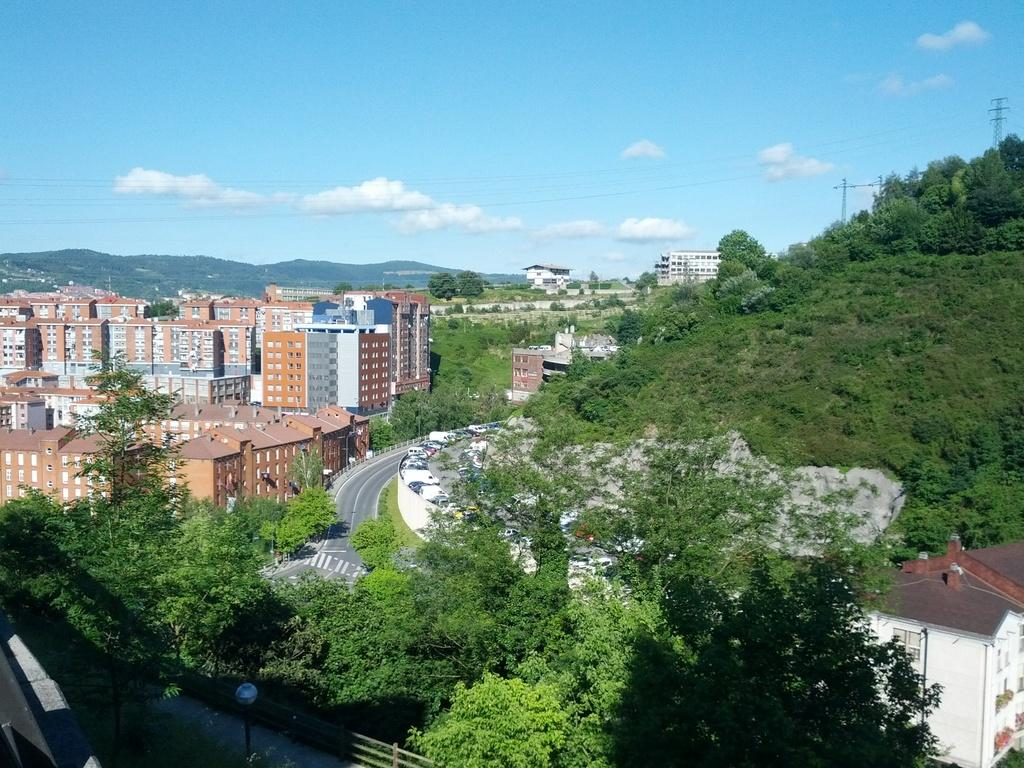What type of vegetation can be seen in the image? There are trees in the image. What is the color of the trees? The trees are green. What can be seen in the background of the image? There are buildings in the background of the image. What colors are the buildings? The buildings have orange, gray, and white colors. What is visible above the trees and buildings in the image? The sky is visible in the image. What colors are present in the sky? The sky has blue and white colors. Can you tell me how many times the trees have been bitten by insects in the image? There is no indication of insect bites on the trees in the image, so it cannot be determined. 